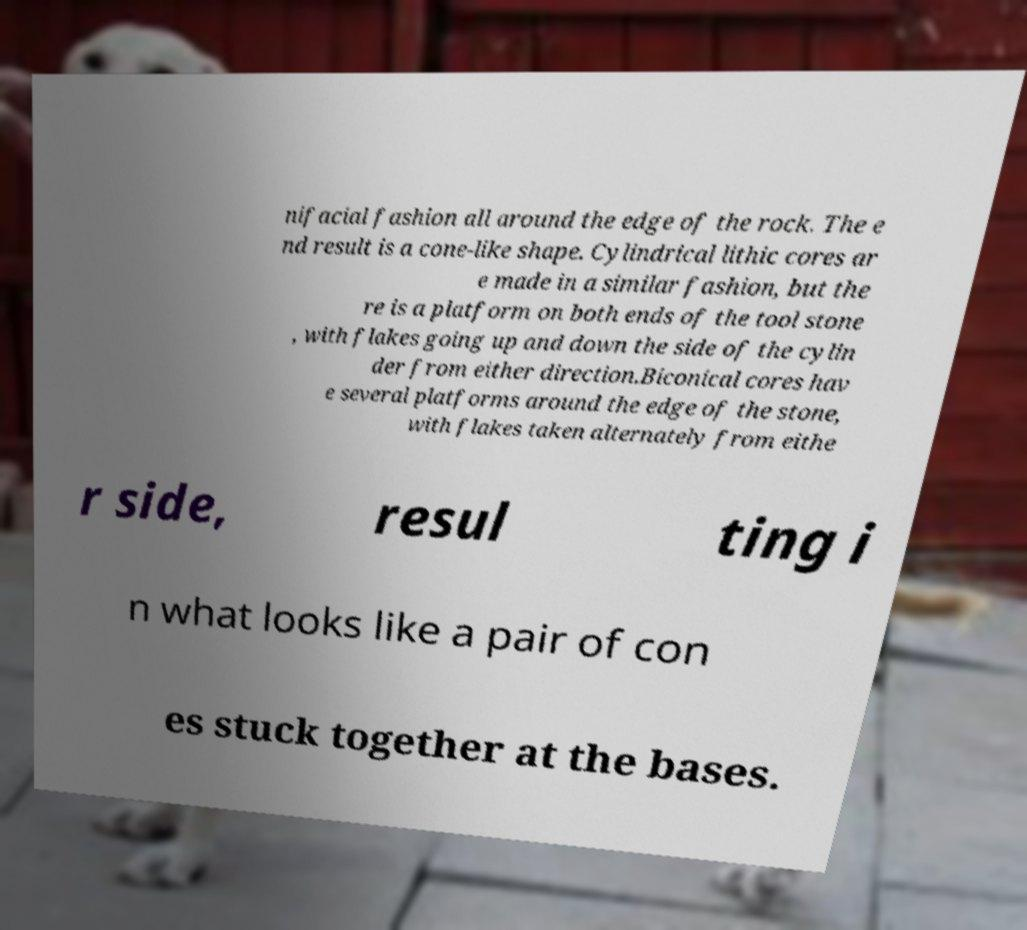Can you accurately transcribe the text from the provided image for me? nifacial fashion all around the edge of the rock. The e nd result is a cone-like shape. Cylindrical lithic cores ar e made in a similar fashion, but the re is a platform on both ends of the tool stone , with flakes going up and down the side of the cylin der from either direction.Biconical cores hav e several platforms around the edge of the stone, with flakes taken alternately from eithe r side, resul ting i n what looks like a pair of con es stuck together at the bases. 